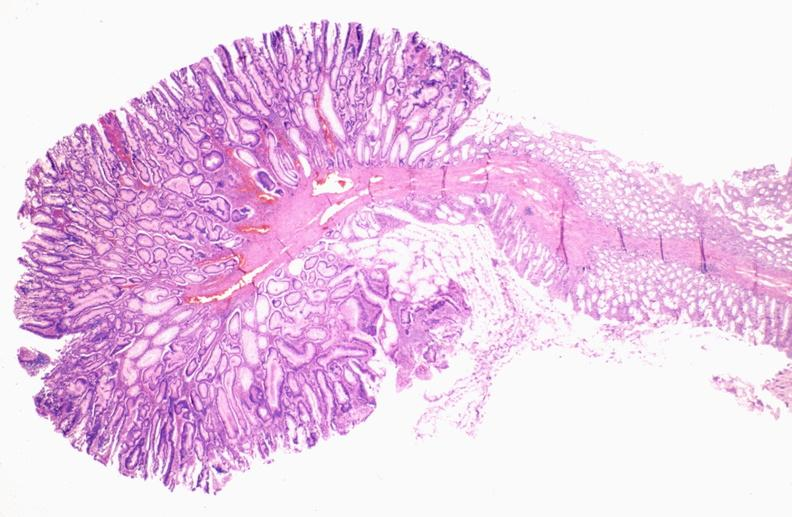s gastrointestinal present?
Answer the question using a single word or phrase. Yes 